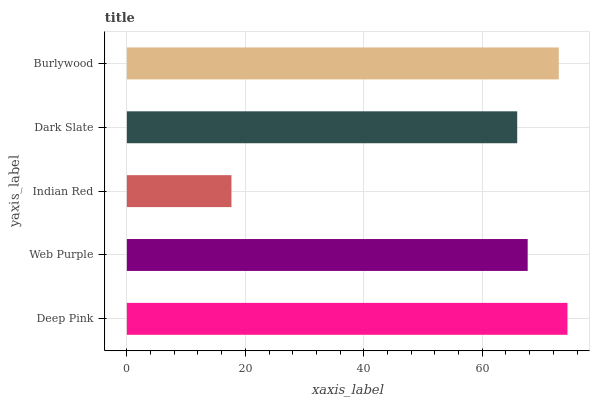Is Indian Red the minimum?
Answer yes or no. Yes. Is Deep Pink the maximum?
Answer yes or no. Yes. Is Web Purple the minimum?
Answer yes or no. No. Is Web Purple the maximum?
Answer yes or no. No. Is Deep Pink greater than Web Purple?
Answer yes or no. Yes. Is Web Purple less than Deep Pink?
Answer yes or no. Yes. Is Web Purple greater than Deep Pink?
Answer yes or no. No. Is Deep Pink less than Web Purple?
Answer yes or no. No. Is Web Purple the high median?
Answer yes or no. Yes. Is Web Purple the low median?
Answer yes or no. Yes. Is Indian Red the high median?
Answer yes or no. No. Is Dark Slate the low median?
Answer yes or no. No. 